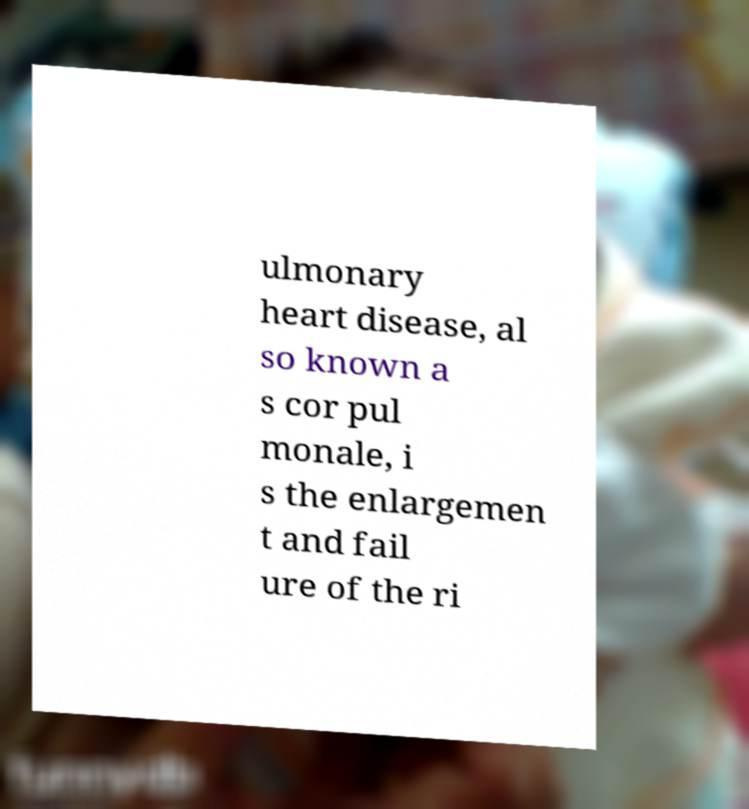I need the written content from this picture converted into text. Can you do that? ulmonary heart disease, al so known a s cor pul monale, i s the enlargemen t and fail ure of the ri 